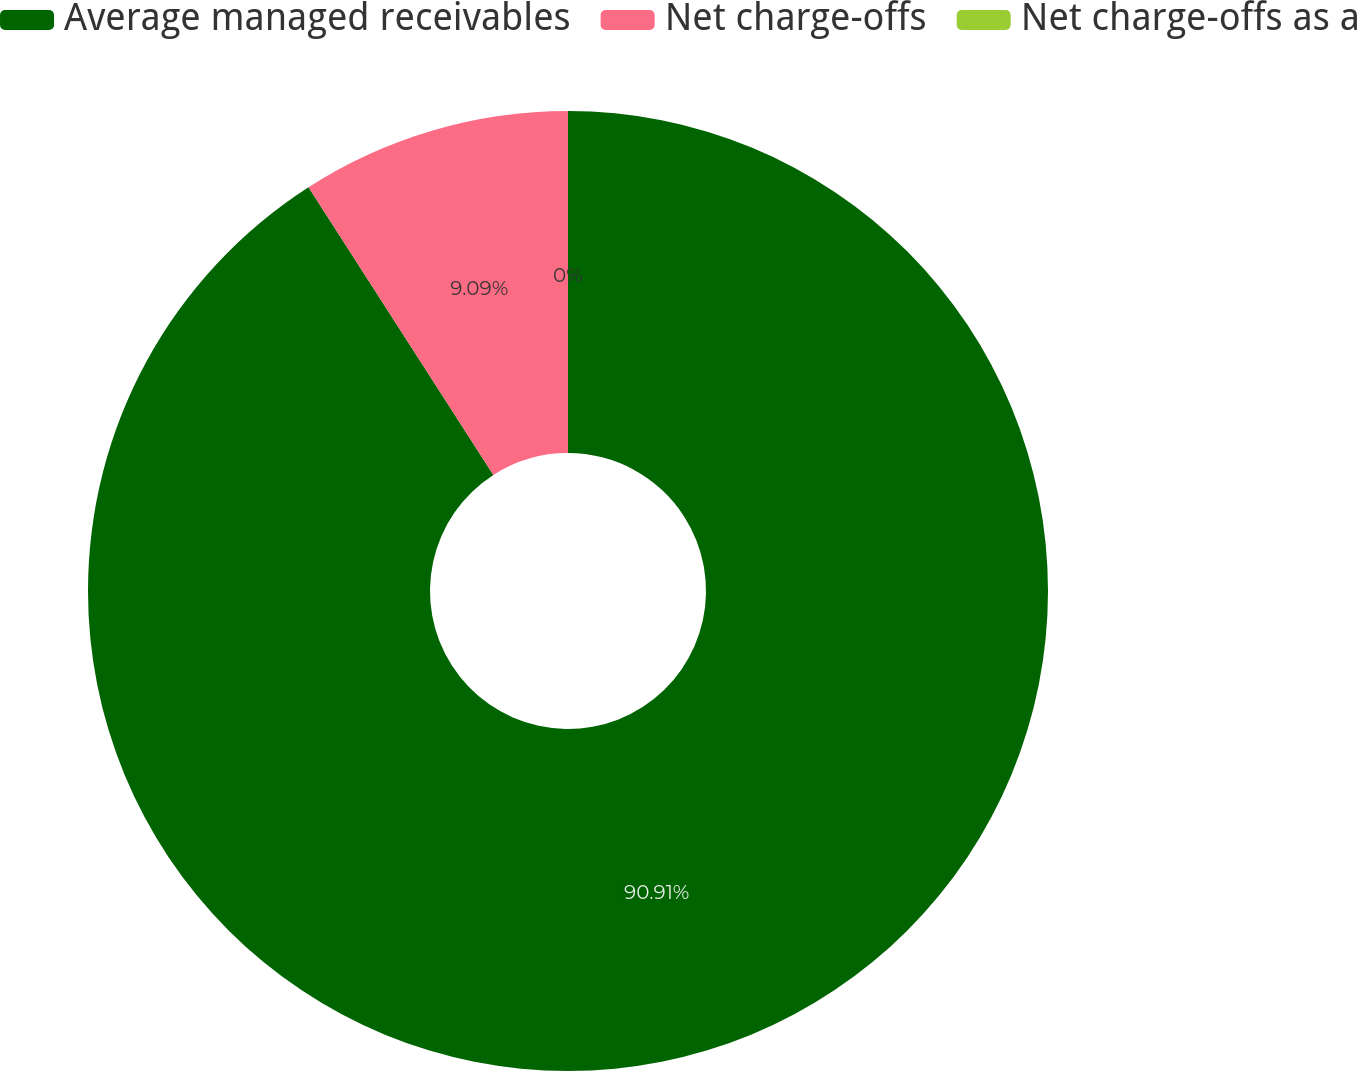Convert chart to OTSL. <chart><loc_0><loc_0><loc_500><loc_500><pie_chart><fcel>Average managed receivables<fcel>Net charge-offs<fcel>Net charge-offs as a<nl><fcel>90.91%<fcel>9.09%<fcel>0.0%<nl></chart> 